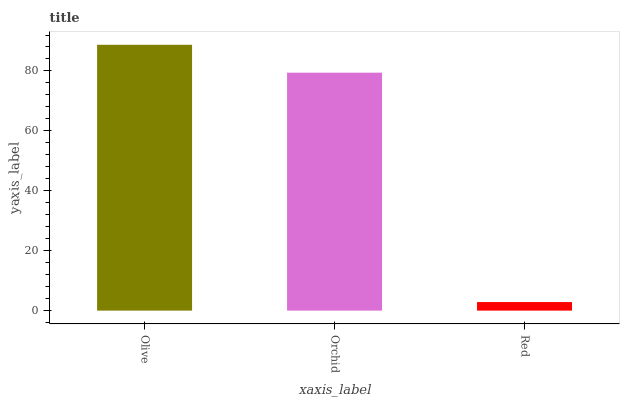Is Red the minimum?
Answer yes or no. Yes. Is Olive the maximum?
Answer yes or no. Yes. Is Orchid the minimum?
Answer yes or no. No. Is Orchid the maximum?
Answer yes or no. No. Is Olive greater than Orchid?
Answer yes or no. Yes. Is Orchid less than Olive?
Answer yes or no. Yes. Is Orchid greater than Olive?
Answer yes or no. No. Is Olive less than Orchid?
Answer yes or no. No. Is Orchid the high median?
Answer yes or no. Yes. Is Orchid the low median?
Answer yes or no. Yes. Is Red the high median?
Answer yes or no. No. Is Red the low median?
Answer yes or no. No. 